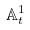Convert formula to latex. <formula><loc_0><loc_0><loc_500><loc_500>\mathbb { A } _ { t } ^ { 1 }</formula> 